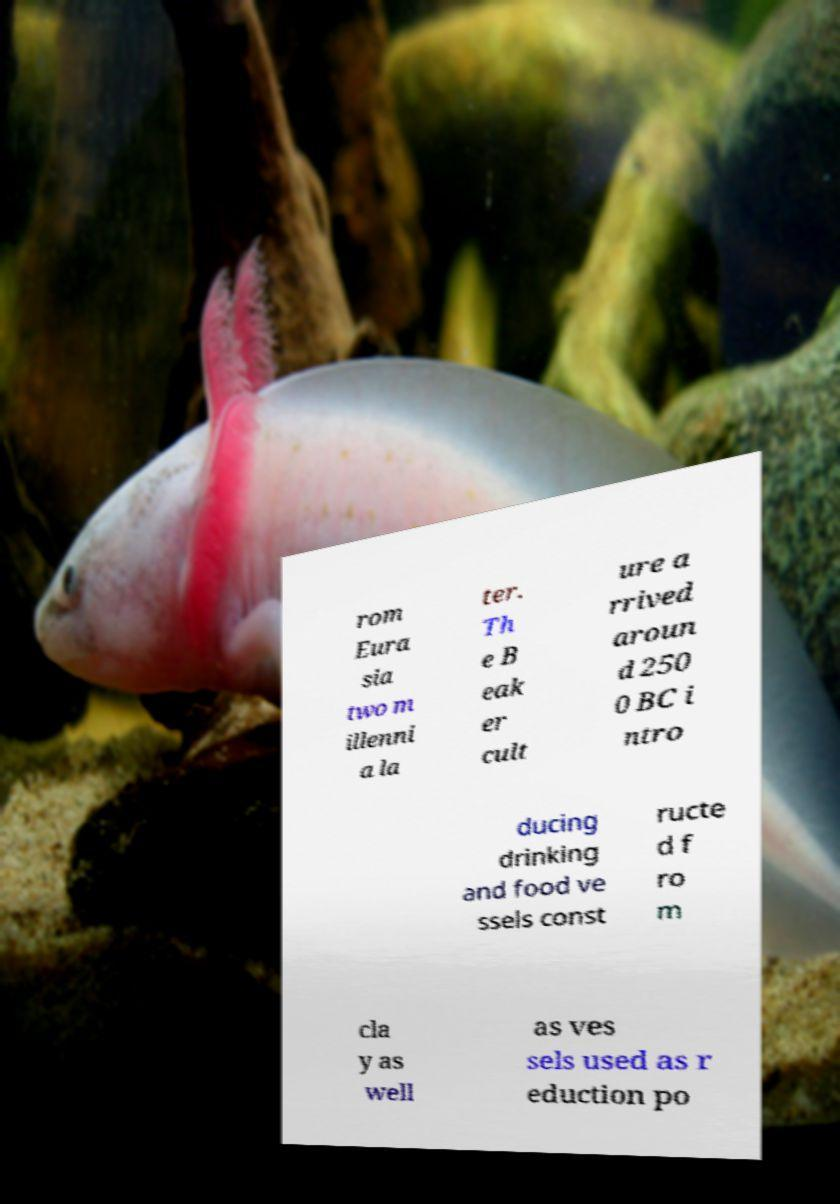There's text embedded in this image that I need extracted. Can you transcribe it verbatim? rom Eura sia two m illenni a la ter. Th e B eak er cult ure a rrived aroun d 250 0 BC i ntro ducing drinking and food ve ssels const ructe d f ro m cla y as well as ves sels used as r eduction po 